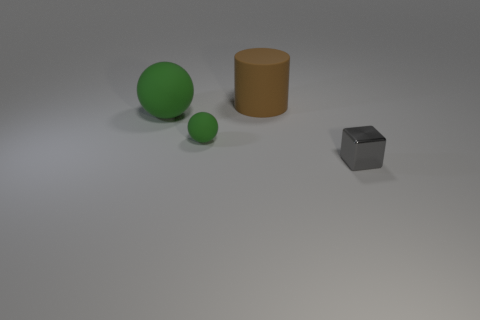Is the tiny green rubber thing the same shape as the big green matte object?
Offer a terse response. Yes. There is a big cylinder that is behind the green matte sphere on the left side of the tiny matte object; what color is it?
Make the answer very short. Brown. There is a rubber thing that is the same size as the rubber cylinder; what is its color?
Offer a terse response. Green. How many rubber objects are either large cyan cylinders or things?
Your response must be concise. 3. There is a gray block that is on the right side of the big brown object; how many rubber cylinders are in front of it?
Keep it short and to the point. 0. What is the size of the thing that is the same color as the big ball?
Provide a succinct answer. Small. What number of things are large gray balls or rubber objects right of the large green ball?
Give a very brief answer. 2. Are there any cylinders made of the same material as the small green thing?
Make the answer very short. Yes. How many things are both behind the tiny ball and right of the large green matte ball?
Provide a succinct answer. 1. There is a small object to the left of the tiny gray thing; what is its material?
Provide a succinct answer. Rubber. 